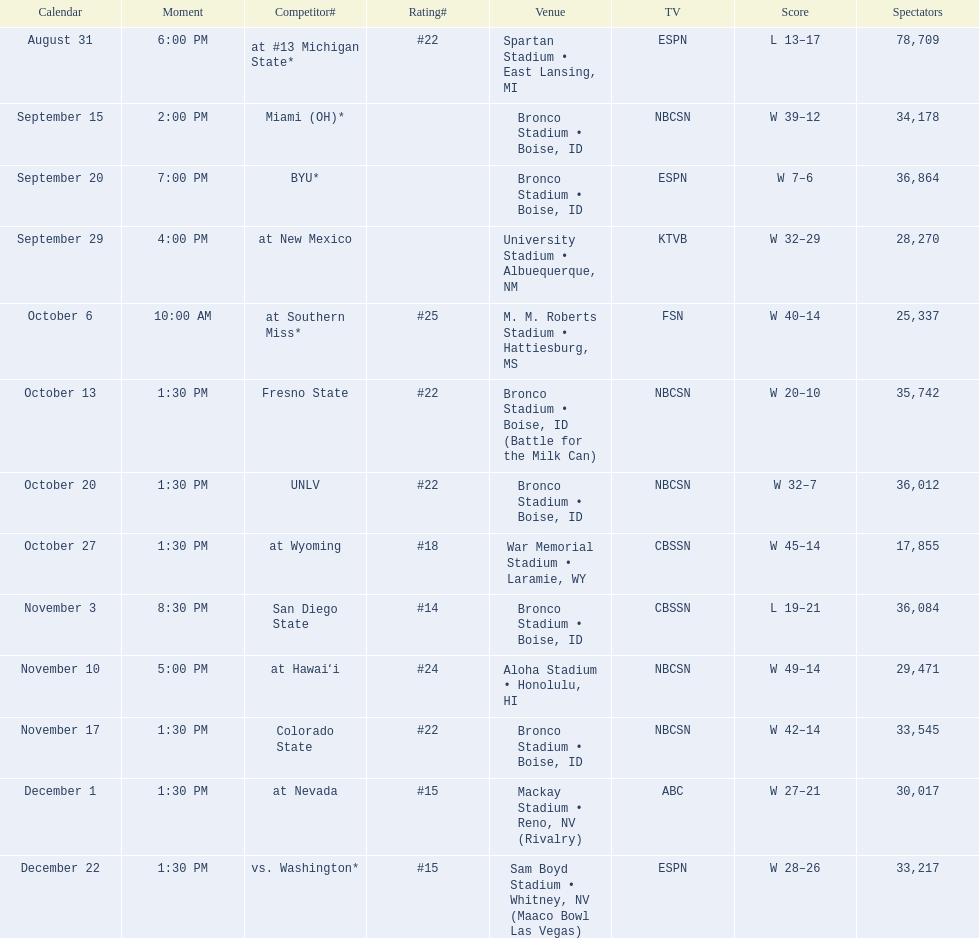What are all of the rankings? #22, , , , #25, #22, #22, #18, #14, #24, #22, #15, #15. Which of them was the best position? #14. 